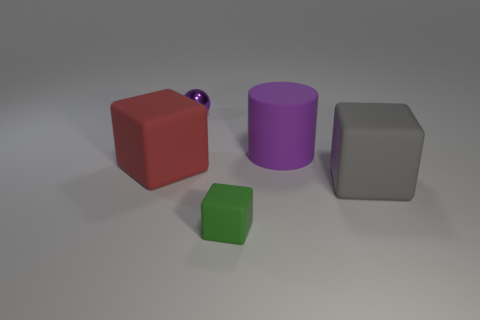What number of cubes are big brown metallic objects or small purple shiny objects?
Provide a short and direct response. 0. The small object that is in front of the big red matte thing has what shape?
Provide a succinct answer. Cube. What color is the matte thing that is on the right side of the big thing behind the large rubber cube on the left side of the large cylinder?
Give a very brief answer. Gray. Does the big purple object have the same material as the small ball?
Give a very brief answer. No. What number of green things are large balls or small rubber blocks?
Your answer should be very brief. 1. There is a large red rubber cube; what number of big cylinders are in front of it?
Provide a succinct answer. 0. Is the number of things greater than the number of large rubber cylinders?
Give a very brief answer. Yes. What is the shape of the big thing in front of the large object to the left of the green object?
Keep it short and to the point. Cube. Is the color of the metal sphere the same as the small block?
Provide a succinct answer. No. Is the number of large rubber cubes that are to the left of the large purple rubber object greater than the number of large blue objects?
Your answer should be compact. Yes. 